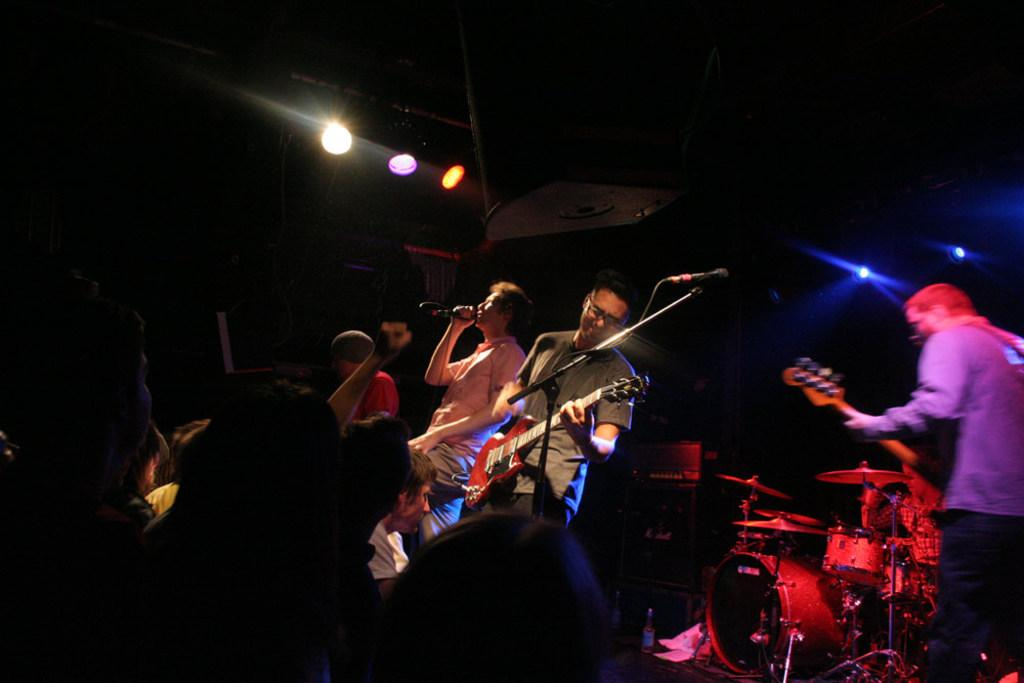How many people are in the image? There is a group of people in the image. What are the people doing in the image? The people are standing and playing a guitar. What equipment is present in the image related to music? There is a microphone, a microphone stand, and musical drums in the image. What can be seen in the image that might be used for amplifying sound? There is a microphone and a microphone stand in the image. What else is present in the image that might be used for lighting purposes? There are lights in the image. How many balloons are being used as part of the game in the image? There are no balloons or games present in the image. What type of drum is being played by the person in the image? The image does not specify the type of drum being played; it only shows musical drums. 